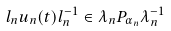<formula> <loc_0><loc_0><loc_500><loc_500>l _ { n } u _ { n } ( t ) l ^ { - 1 } _ { n } \in \lambda _ { n } P _ { \alpha _ { n } } \lambda ^ { - 1 } _ { n }</formula> 